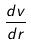<formula> <loc_0><loc_0><loc_500><loc_500>\frac { d v } { d r }</formula> 